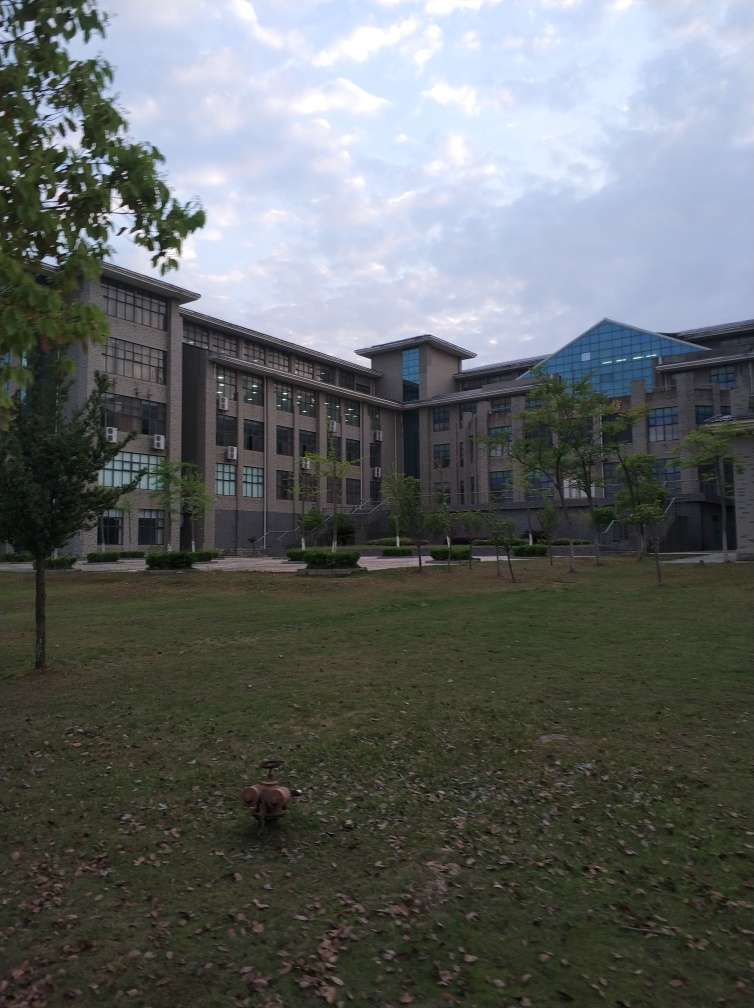Is the overall clarity of the image high? While the image is reasonably clear and the main structures are distinguishable, the lighting is slightly dim, and there appears to be a slight graininess in the sky area. It’s clear enough to make out individual elements like the buildings, trees, and the object on the grass, but it could be sharper for higher clarity. 